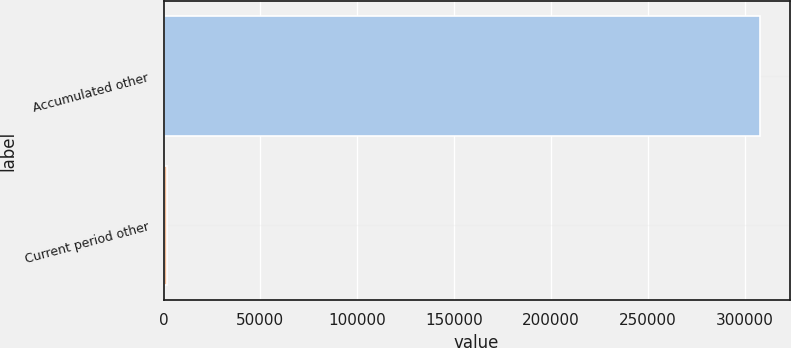Convert chart. <chart><loc_0><loc_0><loc_500><loc_500><bar_chart><fcel>Accumulated other<fcel>Current period other<nl><fcel>307618<fcel>1711<nl></chart> 